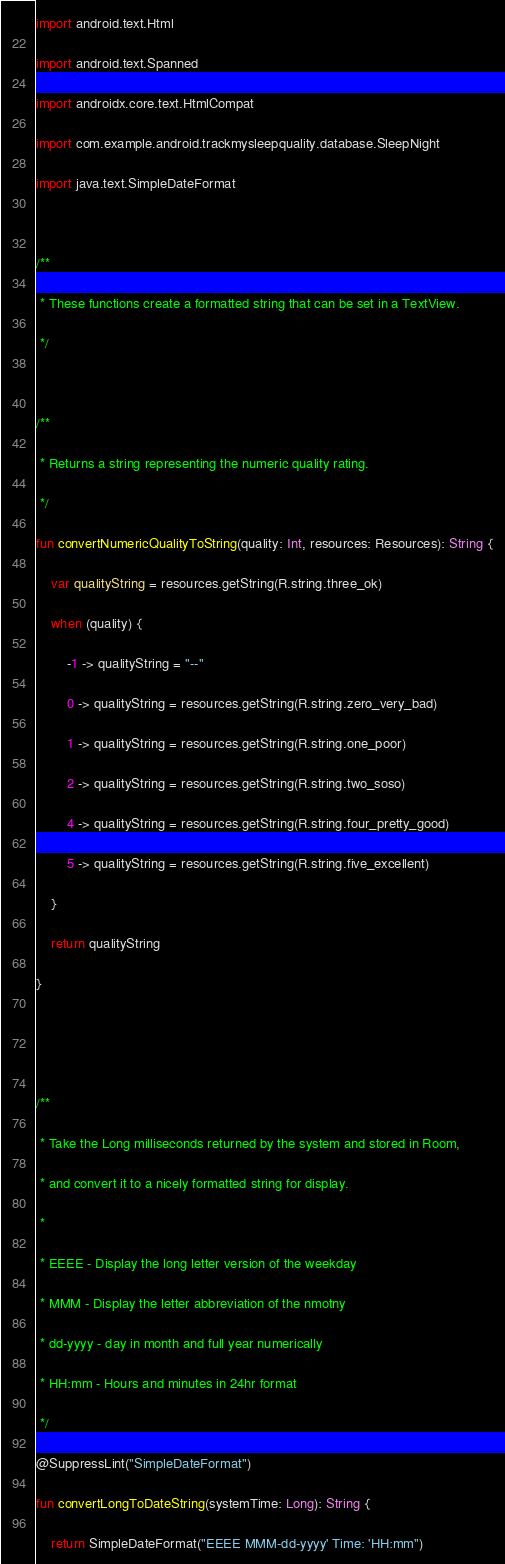Convert code to text. <code><loc_0><loc_0><loc_500><loc_500><_Kotlin_>
import android.text.Html

import android.text.Spanned

import androidx.core.text.HtmlCompat

import com.example.android.trackmysleepquality.database.SleepNight

import java.text.SimpleDateFormat



/**

 * These functions create a formatted string that can be set in a TextView.

 */



/**

 * Returns a string representing the numeric quality rating.

 */

fun convertNumericQualityToString(quality: Int, resources: Resources): String {

    var qualityString = resources.getString(R.string.three_ok)

    when (quality) {

        -1 -> qualityString = "--"

        0 -> qualityString = resources.getString(R.string.zero_very_bad)

        1 -> qualityString = resources.getString(R.string.one_poor)

        2 -> qualityString = resources.getString(R.string.two_soso)

        4 -> qualityString = resources.getString(R.string.four_pretty_good)

        5 -> qualityString = resources.getString(R.string.five_excellent)

    }

    return qualityString

}





/**

 * Take the Long milliseconds returned by the system and stored in Room,

 * and convert it to a nicely formatted string for display.

 *

 * EEEE - Display the long letter version of the weekday

 * MMM - Display the letter abbreviation of the nmotny

 * dd-yyyy - day in month and full year numerically

 * HH:mm - Hours and minutes in 24hr format

 */

@SuppressLint("SimpleDateFormat")

fun convertLongToDateString(systemTime: Long): String {

    return SimpleDateFormat("EEEE MMM-dd-yyyy' Time: 'HH:mm")
</code> 